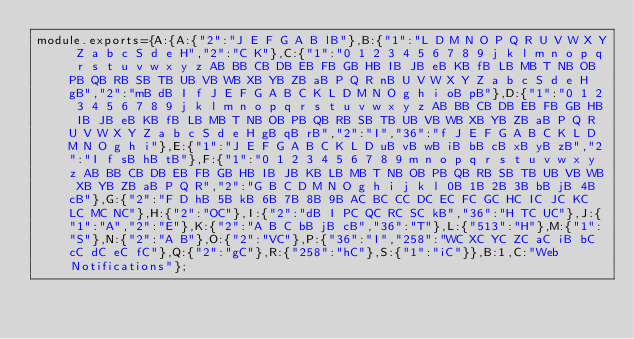Convert code to text. <code><loc_0><loc_0><loc_500><loc_500><_JavaScript_>module.exports={A:{A:{"2":"J E F G A B lB"},B:{"1":"L D M N O P Q R U V W X Y Z a b c S d e H","2":"C K"},C:{"1":"0 1 2 3 4 5 6 7 8 9 j k l m n o p q r s t u v w x y z AB BB CB DB EB FB GB HB IB JB eB KB fB LB MB T NB OB PB QB RB SB TB UB VB WB XB YB ZB aB P Q R nB U V W X Y Z a b c S d e H gB","2":"mB dB I f J E F G A B C K L D M N O g h i oB pB"},D:{"1":"0 1 2 3 4 5 6 7 8 9 j k l m n o p q r s t u v w x y z AB BB CB DB EB FB GB HB IB JB eB KB fB LB MB T NB OB PB QB RB SB TB UB VB WB XB YB ZB aB P Q R U V W X Y Z a b c S d e H gB qB rB","2":"I","36":"f J E F G A B C K L D M N O g h i"},E:{"1":"J E F G A B C K L D uB vB wB iB bB cB xB yB zB","2":"I f sB hB tB"},F:{"1":"0 1 2 3 4 5 6 7 8 9 m n o p q r s t u v w x y z AB BB CB DB EB FB GB HB IB JB KB LB MB T NB OB PB QB RB SB TB UB VB WB XB YB ZB aB P Q R","2":"G B C D M N O g h i j k l 0B 1B 2B 3B bB jB 4B cB"},G:{"2":"F D hB 5B kB 6B 7B 8B 9B AC BC CC DC EC FC GC HC IC JC KC LC MC NC"},H:{"2":"OC"},I:{"2":"dB I PC QC RC SC kB","36":"H TC UC"},J:{"1":"A","2":"E"},K:{"2":"A B C bB jB cB","36":"T"},L:{"513":"H"},M:{"1":"S"},N:{"2":"A B"},O:{"2":"VC"},P:{"36":"I","258":"WC XC YC ZC aC iB bC cC dC eC fC"},Q:{"2":"gC"},R:{"258":"hC"},S:{"1":"iC"}},B:1,C:"Web Notifications"};
</code> 